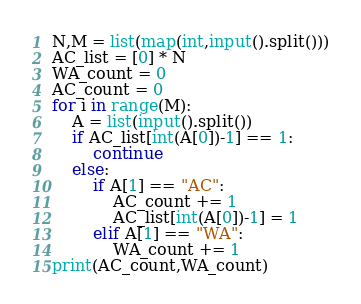Convert code to text. <code><loc_0><loc_0><loc_500><loc_500><_Python_>N,M = list(map(int,input().split()))
AC_list = [0] * N
WA_count = 0
AC_count = 0
for i in range(M):
    A = list(input().split())
    if AC_list[int(A[0])-1] == 1:
        continue
    else:
        if A[1] == "AC":
            AC_count += 1
            AC_list[int(A[0])-1] = 1
        elif A[1] == "WA":
            WA_count += 1
print(AC_count,WA_count)</code> 